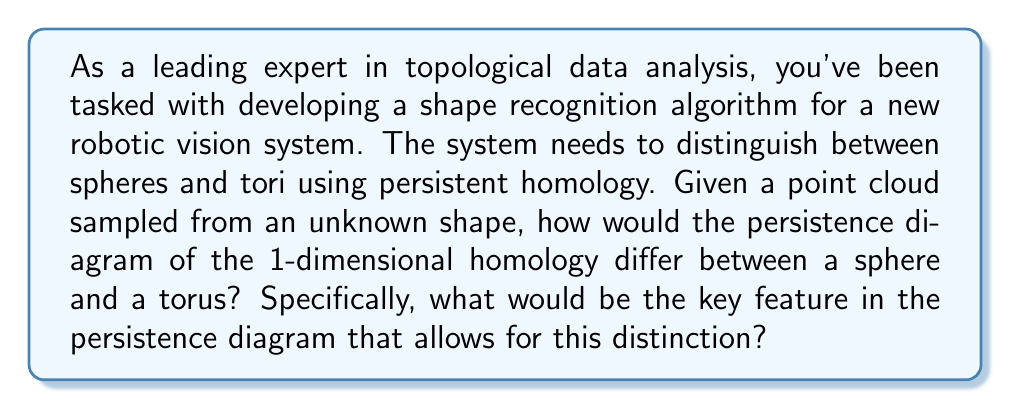Can you answer this question? To answer this question, we need to understand the concept of persistent homology and how it applies to shape recognition, particularly for spheres and tori.

1. Persistent Homology:
Persistent homology is a method in topological data analysis that captures the topological features of a shape across different scales. It creates a multi-scale representation of the shape by growing balls around each point in the point cloud and tracking how topological features (connected components, loops, voids) appear and disappear as the radius increases.

2. Persistence Diagram:
The persistence diagram visualizes the birth and death times of topological features. For 1-dimensional homology, it represents the appearance and disappearance of loops in the shape.

3. Sphere vs. Torus:
Let's consider the topological differences between a sphere and a torus:

   - Sphere: Topologically, a sphere has no 1-dimensional holes (loops that can't be contracted to a point).
   - Torus: A torus has two essential 1-dimensional holes: one around the central hole and one around the body of the torus.

4. Persistence Diagram for Sphere:
For a sphere, the 1-dimensional persistence diagram would show:
   - Many short-lived loops that appear and quickly disappear as the radius increases.
   - No significant long-lasting features in the 1-dimensional homology.

5. Persistence Diagram for Torus:
For a torus, the 1-dimensional persistence diagram would show:
   - Many short-lived loops, similar to the sphere.
   - Crucially, it would also show two points far from the diagonal, representing the two essential loops of the torus that persist for a long time.

6. Key Distinction:
The key feature that distinguishes a torus from a sphere in the 1-dimensional persistence diagram is the presence of two points with high persistence (far from the diagonal). These represent the two essential loops of the torus that do not appear in a sphere.

In mathematical notation, if we denote the persistence of a feature as the difference between its death time $d$ and birth time $b$, we can express this distinction as:

For a torus: $\exists p_1, p_2 \in PD_1 : (d_1 - b_1) \gg 0 \text{ and } (d_2 - b_2) \gg 0$

Where $PD_1$ is the 1-dimensional persistence diagram, and $p_1 = (b_1, d_1)$, $p_2 = (b_2, d_2)$ are the two points representing the essential loops.

For a sphere, no such points with high persistence would exist in the 1-dimensional persistence diagram.
Answer: The key feature in the 1-dimensional persistence diagram that distinguishes a torus from a sphere is the presence of two points far from the diagonal, representing two loops with high persistence. These correspond to the two essential 1-dimensional holes in a torus, which are absent in a sphere. 